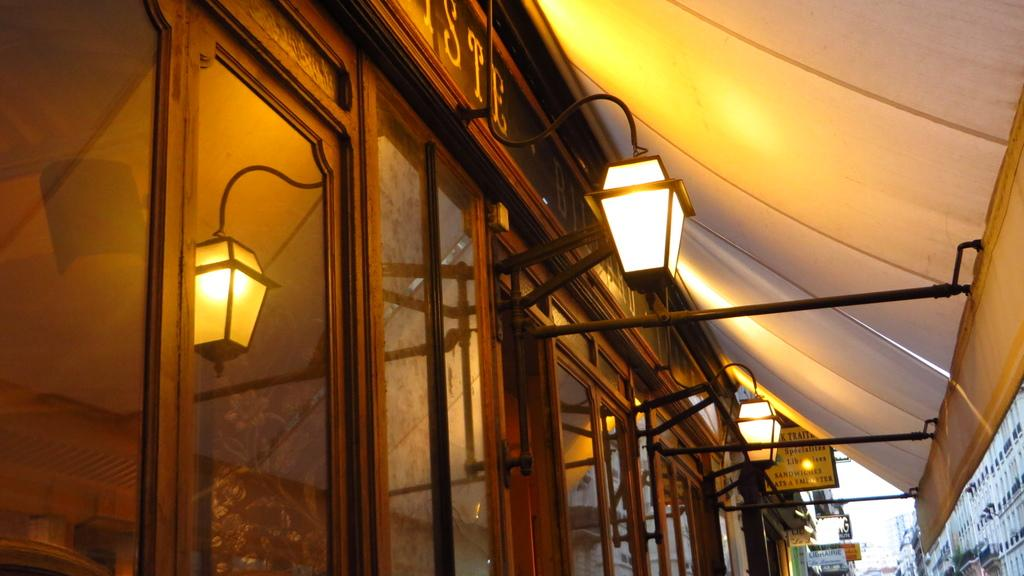What objects are located in the center of the image? There are lamps and doors in the center of the image. What type of decorative items can be seen in the image? There are posters in the image. What structures are visible in the bottom right side of the image? There are buildings in the bottom right side of the image. What type of letter is being delivered to the buildings in the image? There is no letter being delivered in the image; it only shows lamps, doors, posters, and buildings. How quiet is the environment in the image? The image does not provide any information about the noise level or the environment's quietness. 